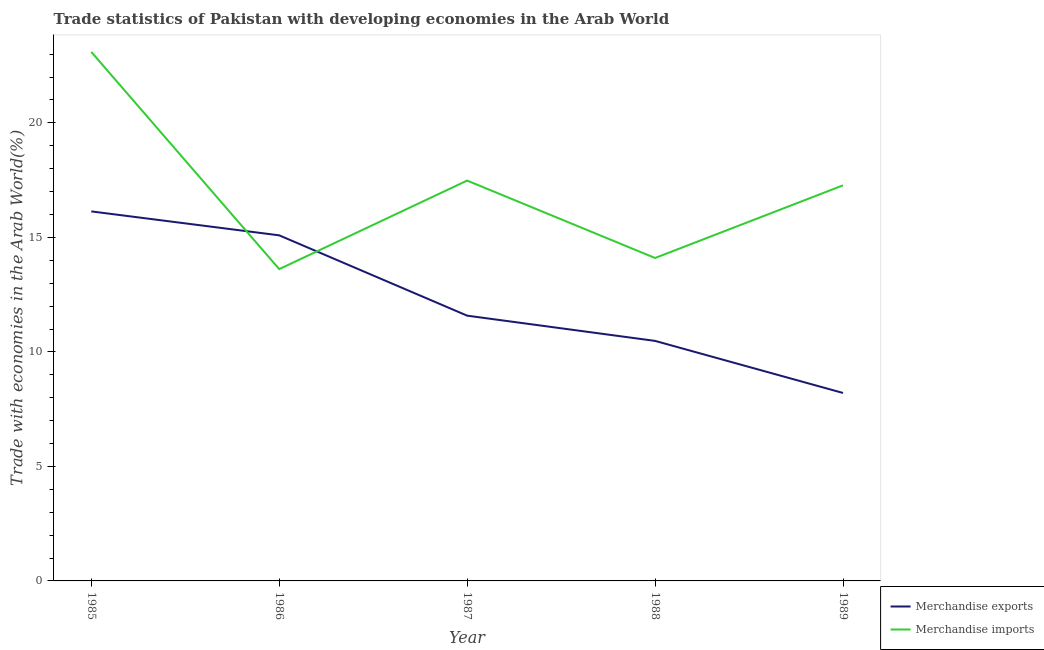Does the line corresponding to merchandise imports intersect with the line corresponding to merchandise exports?
Offer a terse response. Yes. Is the number of lines equal to the number of legend labels?
Give a very brief answer. Yes. What is the merchandise exports in 1988?
Provide a succinct answer. 10.48. Across all years, what is the maximum merchandise imports?
Your answer should be very brief. 23.1. Across all years, what is the minimum merchandise exports?
Your answer should be very brief. 8.21. In which year was the merchandise exports minimum?
Ensure brevity in your answer.  1989. What is the total merchandise exports in the graph?
Provide a succinct answer. 61.49. What is the difference between the merchandise imports in 1985 and that in 1988?
Offer a terse response. 9. What is the difference between the merchandise imports in 1989 and the merchandise exports in 1985?
Provide a succinct answer. 1.14. What is the average merchandise imports per year?
Make the answer very short. 17.11. In the year 1988, what is the difference between the merchandise imports and merchandise exports?
Give a very brief answer. 3.62. What is the ratio of the merchandise imports in 1985 to that in 1987?
Make the answer very short. 1.32. Is the merchandise imports in 1985 less than that in 1986?
Keep it short and to the point. No. What is the difference between the highest and the second highest merchandise imports?
Offer a very short reply. 5.62. What is the difference between the highest and the lowest merchandise imports?
Give a very brief answer. 9.48. Is the merchandise exports strictly less than the merchandise imports over the years?
Offer a terse response. No. What is the difference between two consecutive major ticks on the Y-axis?
Ensure brevity in your answer.  5. Are the values on the major ticks of Y-axis written in scientific E-notation?
Your answer should be very brief. No. Does the graph contain grids?
Your answer should be very brief. No. How are the legend labels stacked?
Offer a terse response. Vertical. What is the title of the graph?
Your answer should be very brief. Trade statistics of Pakistan with developing economies in the Arab World. Does "Import" appear as one of the legend labels in the graph?
Ensure brevity in your answer.  No. What is the label or title of the Y-axis?
Provide a short and direct response. Trade with economies in the Arab World(%). What is the Trade with economies in the Arab World(%) in Merchandise exports in 1985?
Your response must be concise. 16.13. What is the Trade with economies in the Arab World(%) in Merchandise imports in 1985?
Give a very brief answer. 23.1. What is the Trade with economies in the Arab World(%) of Merchandise exports in 1986?
Give a very brief answer. 15.09. What is the Trade with economies in the Arab World(%) in Merchandise imports in 1986?
Give a very brief answer. 13.62. What is the Trade with economies in the Arab World(%) in Merchandise exports in 1987?
Your answer should be very brief. 11.58. What is the Trade with economies in the Arab World(%) in Merchandise imports in 1987?
Provide a succinct answer. 17.48. What is the Trade with economies in the Arab World(%) in Merchandise exports in 1988?
Your response must be concise. 10.48. What is the Trade with economies in the Arab World(%) in Merchandise imports in 1988?
Your response must be concise. 14.1. What is the Trade with economies in the Arab World(%) in Merchandise exports in 1989?
Make the answer very short. 8.21. What is the Trade with economies in the Arab World(%) of Merchandise imports in 1989?
Offer a terse response. 17.27. Across all years, what is the maximum Trade with economies in the Arab World(%) of Merchandise exports?
Provide a short and direct response. 16.13. Across all years, what is the maximum Trade with economies in the Arab World(%) in Merchandise imports?
Ensure brevity in your answer.  23.1. Across all years, what is the minimum Trade with economies in the Arab World(%) of Merchandise exports?
Your response must be concise. 8.21. Across all years, what is the minimum Trade with economies in the Arab World(%) in Merchandise imports?
Make the answer very short. 13.62. What is the total Trade with economies in the Arab World(%) of Merchandise exports in the graph?
Your answer should be compact. 61.49. What is the total Trade with economies in the Arab World(%) of Merchandise imports in the graph?
Give a very brief answer. 85.57. What is the difference between the Trade with economies in the Arab World(%) of Merchandise exports in 1985 and that in 1986?
Offer a terse response. 1.04. What is the difference between the Trade with economies in the Arab World(%) of Merchandise imports in 1985 and that in 1986?
Offer a terse response. 9.48. What is the difference between the Trade with economies in the Arab World(%) of Merchandise exports in 1985 and that in 1987?
Your answer should be compact. 4.55. What is the difference between the Trade with economies in the Arab World(%) in Merchandise imports in 1985 and that in 1987?
Offer a terse response. 5.62. What is the difference between the Trade with economies in the Arab World(%) of Merchandise exports in 1985 and that in 1988?
Your response must be concise. 5.65. What is the difference between the Trade with economies in the Arab World(%) of Merchandise imports in 1985 and that in 1988?
Ensure brevity in your answer.  9. What is the difference between the Trade with economies in the Arab World(%) of Merchandise exports in 1985 and that in 1989?
Your response must be concise. 7.93. What is the difference between the Trade with economies in the Arab World(%) of Merchandise imports in 1985 and that in 1989?
Provide a succinct answer. 5.83. What is the difference between the Trade with economies in the Arab World(%) in Merchandise exports in 1986 and that in 1987?
Make the answer very short. 3.51. What is the difference between the Trade with economies in the Arab World(%) in Merchandise imports in 1986 and that in 1987?
Ensure brevity in your answer.  -3.87. What is the difference between the Trade with economies in the Arab World(%) in Merchandise exports in 1986 and that in 1988?
Offer a very short reply. 4.61. What is the difference between the Trade with economies in the Arab World(%) in Merchandise imports in 1986 and that in 1988?
Give a very brief answer. -0.48. What is the difference between the Trade with economies in the Arab World(%) in Merchandise exports in 1986 and that in 1989?
Make the answer very short. 6.88. What is the difference between the Trade with economies in the Arab World(%) in Merchandise imports in 1986 and that in 1989?
Offer a terse response. -3.66. What is the difference between the Trade with economies in the Arab World(%) in Merchandise exports in 1987 and that in 1988?
Offer a terse response. 1.1. What is the difference between the Trade with economies in the Arab World(%) of Merchandise imports in 1987 and that in 1988?
Ensure brevity in your answer.  3.38. What is the difference between the Trade with economies in the Arab World(%) of Merchandise exports in 1987 and that in 1989?
Your response must be concise. 3.38. What is the difference between the Trade with economies in the Arab World(%) in Merchandise imports in 1987 and that in 1989?
Ensure brevity in your answer.  0.21. What is the difference between the Trade with economies in the Arab World(%) in Merchandise exports in 1988 and that in 1989?
Make the answer very short. 2.27. What is the difference between the Trade with economies in the Arab World(%) in Merchandise imports in 1988 and that in 1989?
Make the answer very short. -3.17. What is the difference between the Trade with economies in the Arab World(%) in Merchandise exports in 1985 and the Trade with economies in the Arab World(%) in Merchandise imports in 1986?
Give a very brief answer. 2.52. What is the difference between the Trade with economies in the Arab World(%) of Merchandise exports in 1985 and the Trade with economies in the Arab World(%) of Merchandise imports in 1987?
Your answer should be compact. -1.35. What is the difference between the Trade with economies in the Arab World(%) in Merchandise exports in 1985 and the Trade with economies in the Arab World(%) in Merchandise imports in 1988?
Ensure brevity in your answer.  2.03. What is the difference between the Trade with economies in the Arab World(%) in Merchandise exports in 1985 and the Trade with economies in the Arab World(%) in Merchandise imports in 1989?
Your response must be concise. -1.14. What is the difference between the Trade with economies in the Arab World(%) of Merchandise exports in 1986 and the Trade with economies in the Arab World(%) of Merchandise imports in 1987?
Your answer should be very brief. -2.39. What is the difference between the Trade with economies in the Arab World(%) of Merchandise exports in 1986 and the Trade with economies in the Arab World(%) of Merchandise imports in 1988?
Your answer should be compact. 0.99. What is the difference between the Trade with economies in the Arab World(%) in Merchandise exports in 1986 and the Trade with economies in the Arab World(%) in Merchandise imports in 1989?
Provide a succinct answer. -2.18. What is the difference between the Trade with economies in the Arab World(%) of Merchandise exports in 1987 and the Trade with economies in the Arab World(%) of Merchandise imports in 1988?
Provide a short and direct response. -2.52. What is the difference between the Trade with economies in the Arab World(%) in Merchandise exports in 1987 and the Trade with economies in the Arab World(%) in Merchandise imports in 1989?
Give a very brief answer. -5.69. What is the difference between the Trade with economies in the Arab World(%) of Merchandise exports in 1988 and the Trade with economies in the Arab World(%) of Merchandise imports in 1989?
Keep it short and to the point. -6.79. What is the average Trade with economies in the Arab World(%) of Merchandise exports per year?
Your answer should be compact. 12.3. What is the average Trade with economies in the Arab World(%) of Merchandise imports per year?
Provide a short and direct response. 17.11. In the year 1985, what is the difference between the Trade with economies in the Arab World(%) in Merchandise exports and Trade with economies in the Arab World(%) in Merchandise imports?
Offer a very short reply. -6.96. In the year 1986, what is the difference between the Trade with economies in the Arab World(%) in Merchandise exports and Trade with economies in the Arab World(%) in Merchandise imports?
Provide a short and direct response. 1.47. In the year 1987, what is the difference between the Trade with economies in the Arab World(%) of Merchandise exports and Trade with economies in the Arab World(%) of Merchandise imports?
Your answer should be very brief. -5.9. In the year 1988, what is the difference between the Trade with economies in the Arab World(%) in Merchandise exports and Trade with economies in the Arab World(%) in Merchandise imports?
Your answer should be compact. -3.62. In the year 1989, what is the difference between the Trade with economies in the Arab World(%) in Merchandise exports and Trade with economies in the Arab World(%) in Merchandise imports?
Keep it short and to the point. -9.07. What is the ratio of the Trade with economies in the Arab World(%) in Merchandise exports in 1985 to that in 1986?
Ensure brevity in your answer.  1.07. What is the ratio of the Trade with economies in the Arab World(%) of Merchandise imports in 1985 to that in 1986?
Your answer should be compact. 1.7. What is the ratio of the Trade with economies in the Arab World(%) of Merchandise exports in 1985 to that in 1987?
Your answer should be very brief. 1.39. What is the ratio of the Trade with economies in the Arab World(%) of Merchandise imports in 1985 to that in 1987?
Give a very brief answer. 1.32. What is the ratio of the Trade with economies in the Arab World(%) in Merchandise exports in 1985 to that in 1988?
Your answer should be very brief. 1.54. What is the ratio of the Trade with economies in the Arab World(%) in Merchandise imports in 1985 to that in 1988?
Your response must be concise. 1.64. What is the ratio of the Trade with economies in the Arab World(%) of Merchandise exports in 1985 to that in 1989?
Provide a short and direct response. 1.97. What is the ratio of the Trade with economies in the Arab World(%) in Merchandise imports in 1985 to that in 1989?
Your answer should be compact. 1.34. What is the ratio of the Trade with economies in the Arab World(%) in Merchandise exports in 1986 to that in 1987?
Your answer should be very brief. 1.3. What is the ratio of the Trade with economies in the Arab World(%) of Merchandise imports in 1986 to that in 1987?
Give a very brief answer. 0.78. What is the ratio of the Trade with economies in the Arab World(%) in Merchandise exports in 1986 to that in 1988?
Provide a short and direct response. 1.44. What is the ratio of the Trade with economies in the Arab World(%) in Merchandise imports in 1986 to that in 1988?
Provide a short and direct response. 0.97. What is the ratio of the Trade with economies in the Arab World(%) of Merchandise exports in 1986 to that in 1989?
Your response must be concise. 1.84. What is the ratio of the Trade with economies in the Arab World(%) in Merchandise imports in 1986 to that in 1989?
Offer a terse response. 0.79. What is the ratio of the Trade with economies in the Arab World(%) of Merchandise exports in 1987 to that in 1988?
Your answer should be compact. 1.11. What is the ratio of the Trade with economies in the Arab World(%) of Merchandise imports in 1987 to that in 1988?
Make the answer very short. 1.24. What is the ratio of the Trade with economies in the Arab World(%) of Merchandise exports in 1987 to that in 1989?
Give a very brief answer. 1.41. What is the ratio of the Trade with economies in the Arab World(%) of Merchandise imports in 1987 to that in 1989?
Provide a succinct answer. 1.01. What is the ratio of the Trade with economies in the Arab World(%) of Merchandise exports in 1988 to that in 1989?
Give a very brief answer. 1.28. What is the ratio of the Trade with economies in the Arab World(%) of Merchandise imports in 1988 to that in 1989?
Provide a short and direct response. 0.82. What is the difference between the highest and the second highest Trade with economies in the Arab World(%) in Merchandise exports?
Give a very brief answer. 1.04. What is the difference between the highest and the second highest Trade with economies in the Arab World(%) in Merchandise imports?
Offer a very short reply. 5.62. What is the difference between the highest and the lowest Trade with economies in the Arab World(%) in Merchandise exports?
Your answer should be compact. 7.93. What is the difference between the highest and the lowest Trade with economies in the Arab World(%) in Merchandise imports?
Provide a short and direct response. 9.48. 